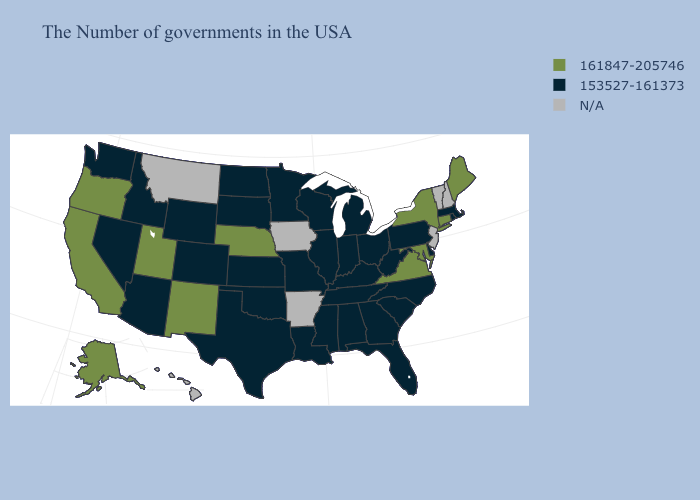Name the states that have a value in the range N/A?
Give a very brief answer. New Hampshire, Vermont, New Jersey, Arkansas, Iowa, Montana, Hawaii. What is the highest value in the Northeast ?
Short answer required. 161847-205746. What is the value of Colorado?
Write a very short answer. 153527-161373. Does Georgia have the highest value in the USA?
Short answer required. No. What is the value of Michigan?
Answer briefly. 153527-161373. Does Georgia have the lowest value in the USA?
Be succinct. Yes. What is the lowest value in states that border Florida?
Keep it brief. 153527-161373. What is the value of South Dakota?
Answer briefly. 153527-161373. Which states have the lowest value in the West?
Keep it brief. Wyoming, Colorado, Arizona, Idaho, Nevada, Washington. Is the legend a continuous bar?
Write a very short answer. No. Does Georgia have the highest value in the USA?
Keep it brief. No. What is the lowest value in the USA?
Keep it brief. 153527-161373. 